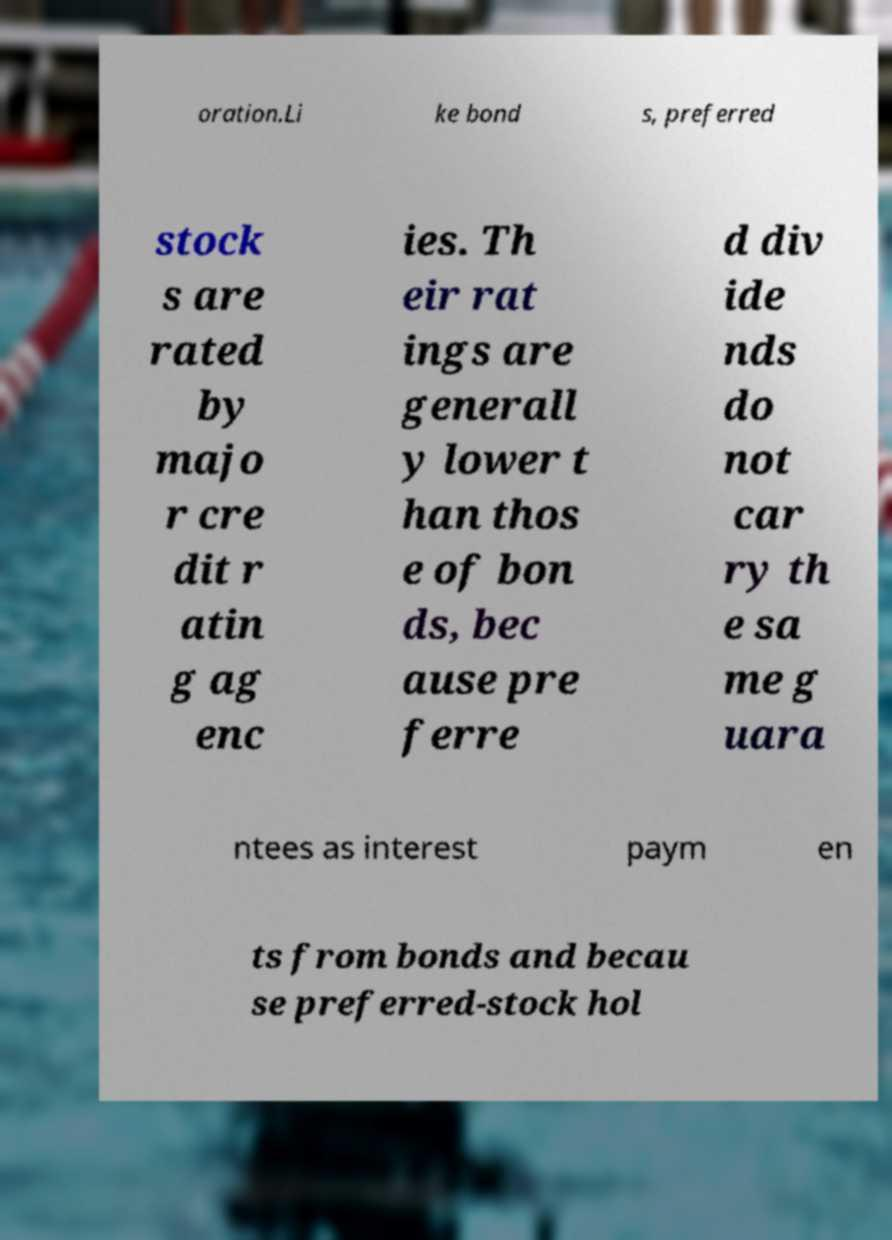Please identify and transcribe the text found in this image. oration.Li ke bond s, preferred stock s are rated by majo r cre dit r atin g ag enc ies. Th eir rat ings are generall y lower t han thos e of bon ds, bec ause pre ferre d div ide nds do not car ry th e sa me g uara ntees as interest paym en ts from bonds and becau se preferred-stock hol 